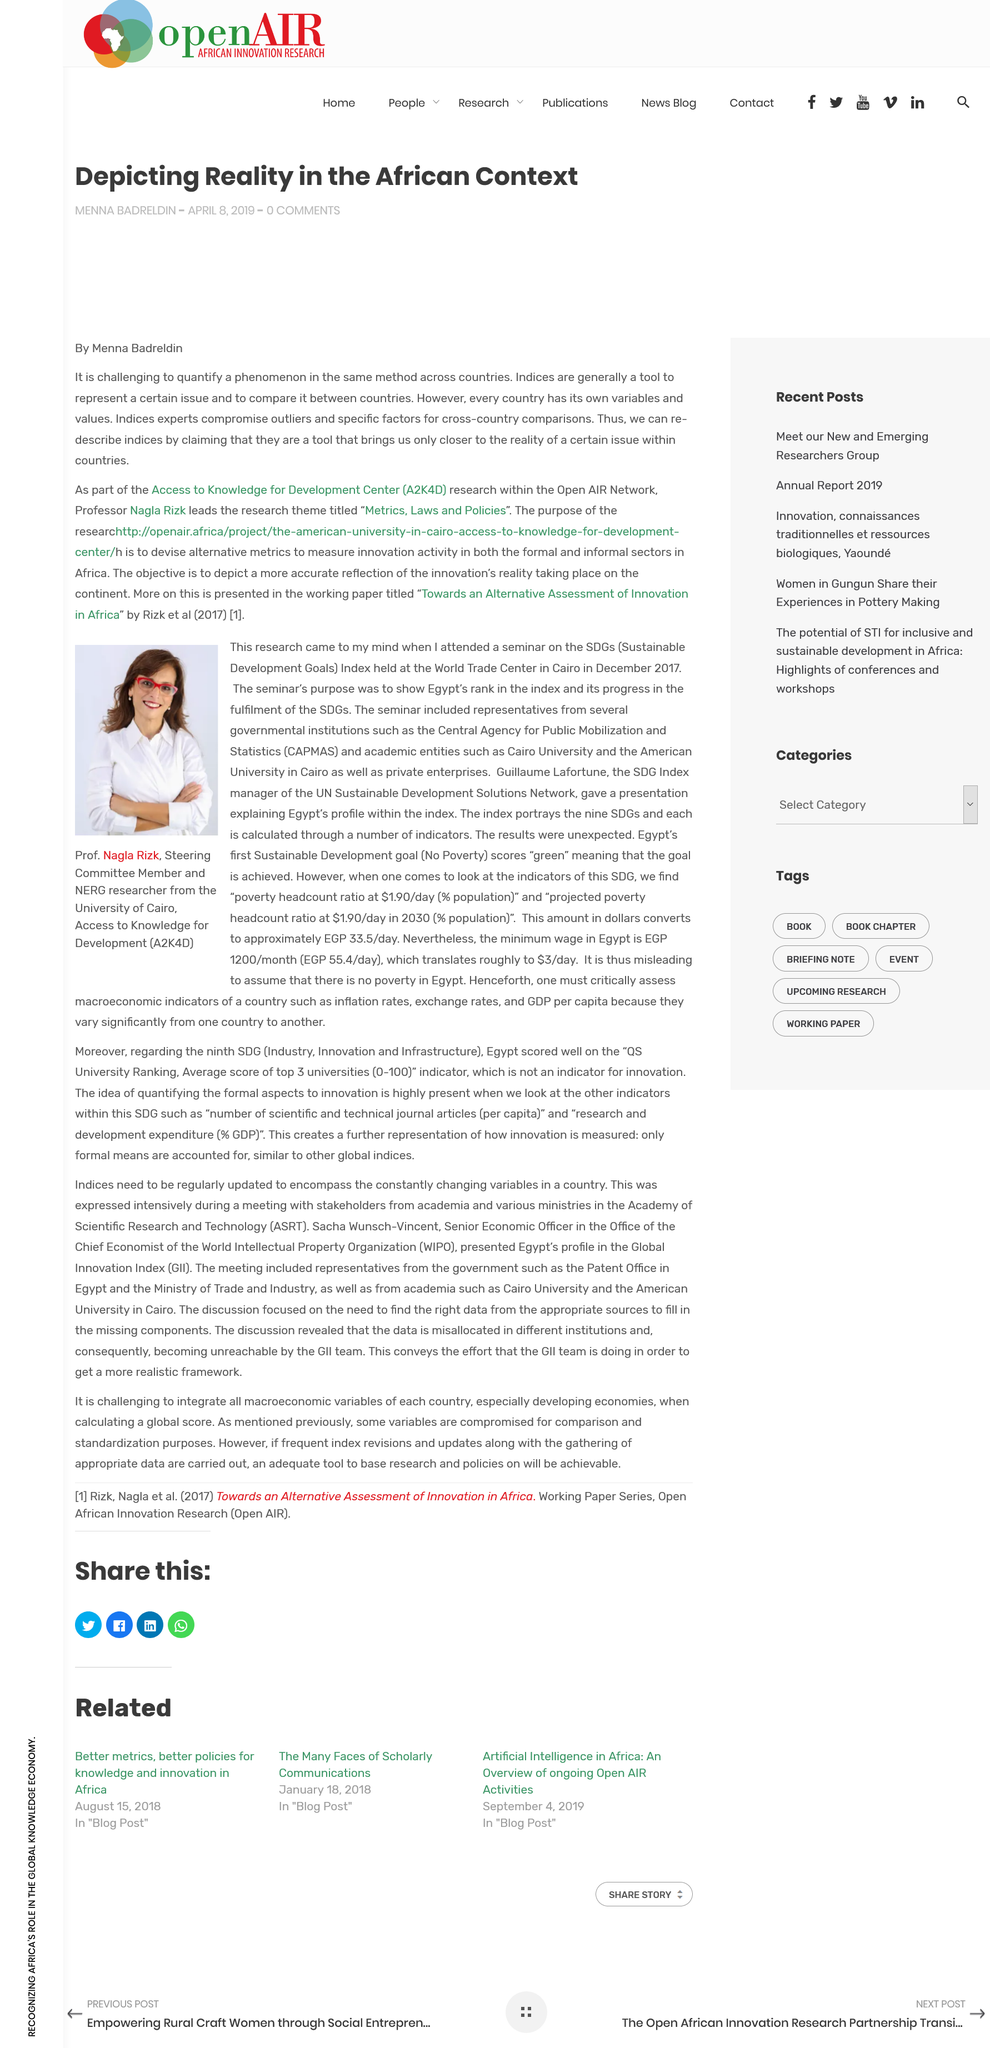Point out several critical features in this image. Menna Badreldin wrote the article. Professor Nagla Rizk's research focuses on the intersections of metrics, laws, and policies. The acronym "A2K4D" stands for "Access to Knowledge for Development Center. 